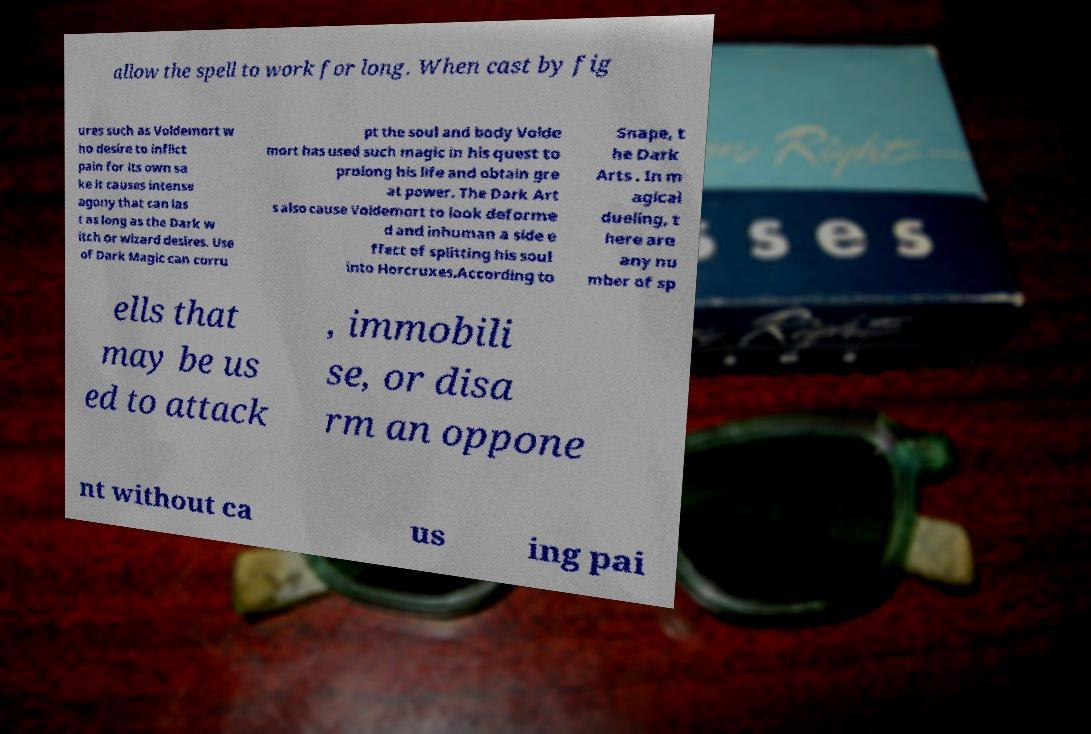Please identify and transcribe the text found in this image. allow the spell to work for long. When cast by fig ures such as Voldemort w ho desire to inflict pain for its own sa ke it causes intense agony that can las t as long as the Dark w itch or wizard desires. Use of Dark Magic can corru pt the soul and body Volde mort has used such magic in his quest to prolong his life and obtain gre at power. The Dark Art s also cause Voldemort to look deforme d and inhuman a side e ffect of splitting his soul into Horcruxes.According to Snape, t he Dark Arts . In m agical dueling, t here are any nu mber of sp ells that may be us ed to attack , immobili se, or disa rm an oppone nt without ca us ing pai 